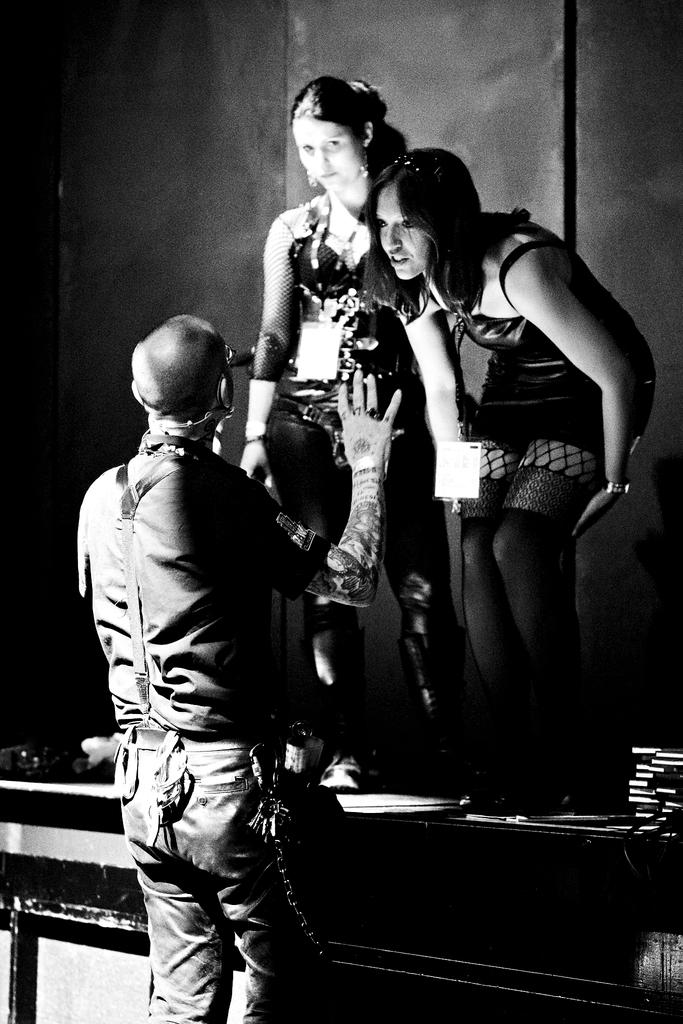How many women are present in the image? There are two women in the image. Where are the women located in the image? The women are standing on a stage. Can you describe the presence of other people in the image? There is a person standing on the floor in the image. What type of vest can be seen on the seashore in the image? There is no seashore or vest present in the image; it features two women standing on a stage and a person standing on the floor. 